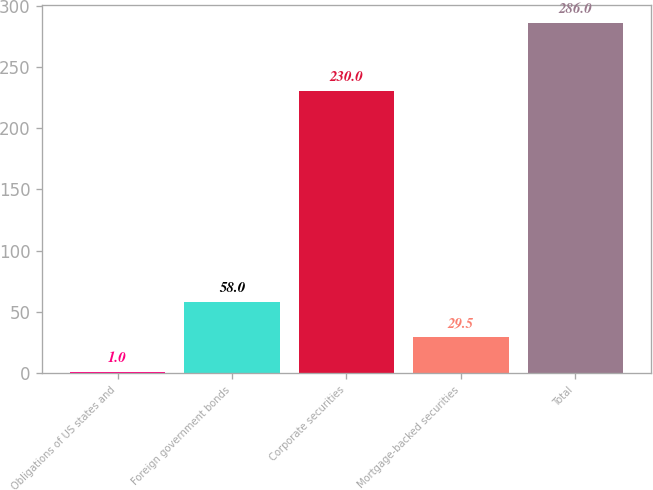<chart> <loc_0><loc_0><loc_500><loc_500><bar_chart><fcel>Obligations of US states and<fcel>Foreign government bonds<fcel>Corporate securities<fcel>Mortgage-backed securities<fcel>Total<nl><fcel>1<fcel>58<fcel>230<fcel>29.5<fcel>286<nl></chart> 